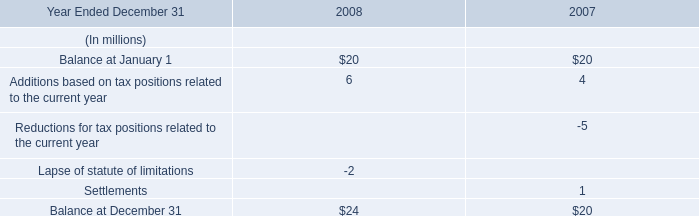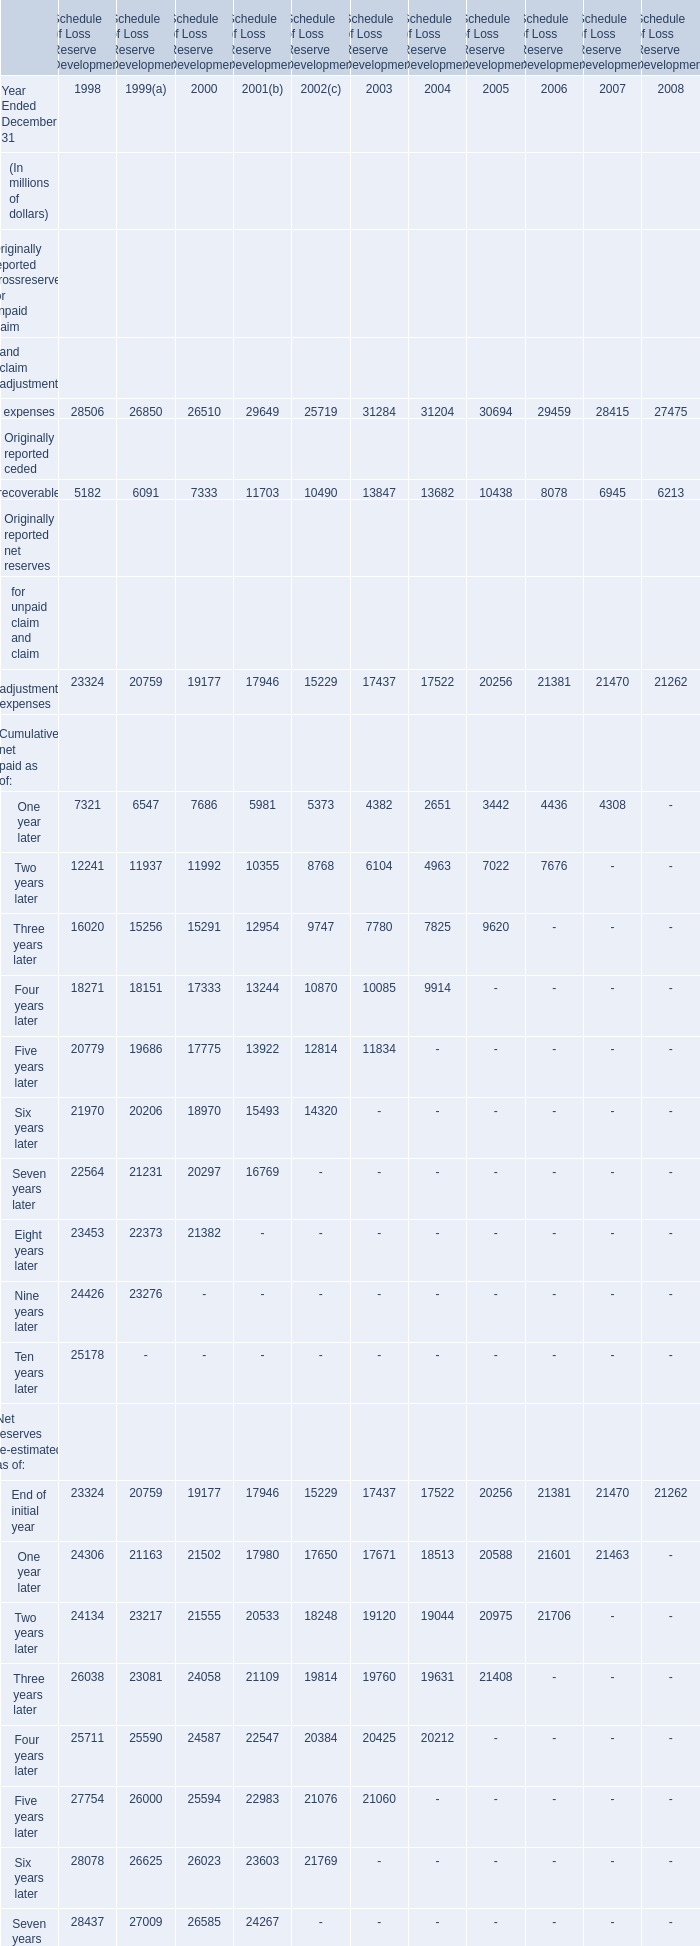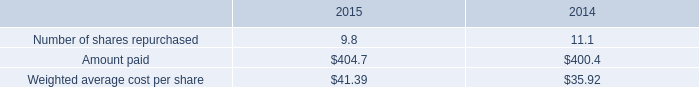What's the average of the End of initial year for Net reserves re-estimated as of in the years where Balance at January 1 is positive? (in million) 
Computations: ((21470 + 21262) / 2)
Answer: 21366.0. How many Environmental claims exceed the average ? (in million) 
Answer: 10. 